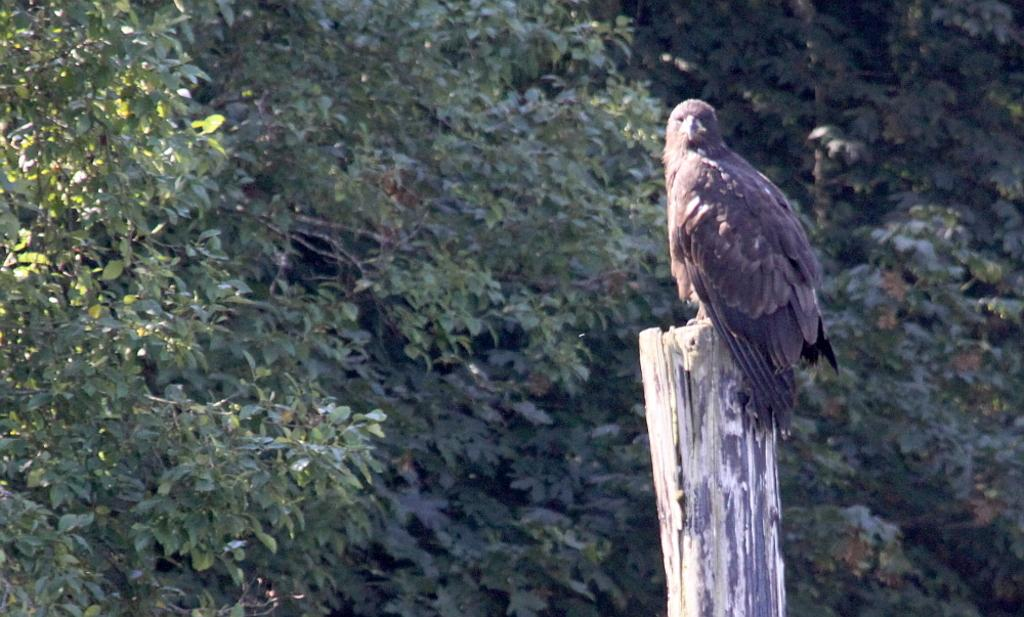What is the main subject of the image? There is a bird on a wood log in the image. Where is the bird located in relation to the image? The bird is on the right side of the image. What can be seen in the background of the image? There are trees in the background of the image. What type of gun is the bird holding in the image? There is no gun present in the image; the bird is simply perched on a wood log. 